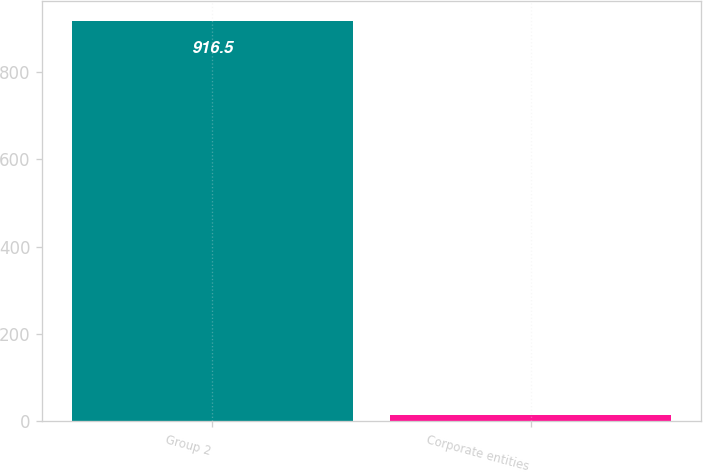Convert chart to OTSL. <chart><loc_0><loc_0><loc_500><loc_500><bar_chart><fcel>Group 2<fcel>Corporate entities<nl><fcel>916.5<fcel>13.6<nl></chart> 